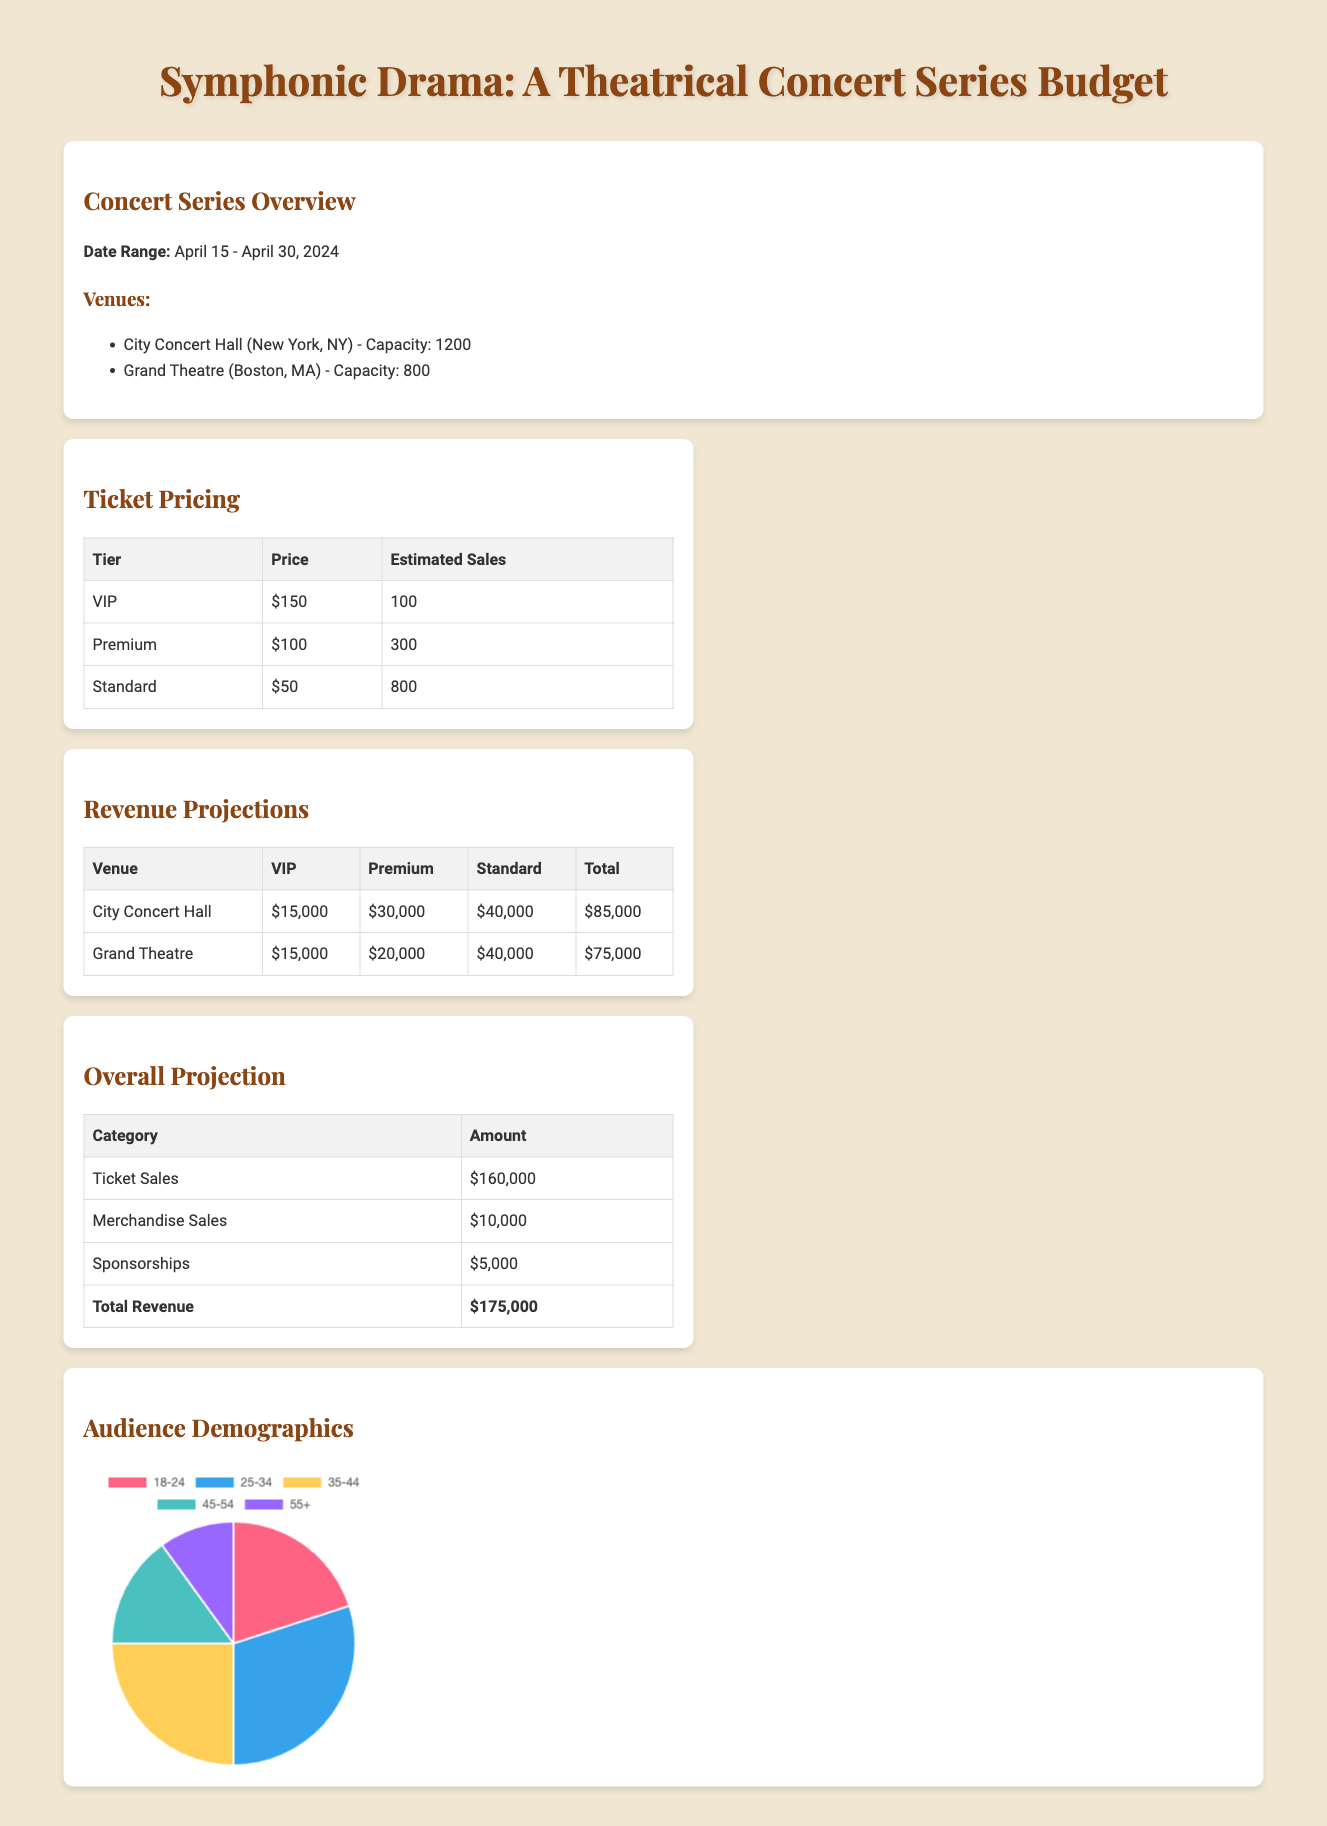What is the total projected ticket sales? The total projected ticket sales amount is listed under overall projection as $160,000.
Answer: $160,000 What is the capacity of the Grand Theatre? The capacity of the Grand Theatre is specified in the concert series overview as 800.
Answer: 800 How many estimated VIP tickets will be sold? The estimated sales for VIP tickets are provided in the ticket pricing section as 100.
Answer: 100 What is the price of a Premium ticket? The pricing tier for a Premium ticket is mentioned in the ticket pricing table as $100.
Answer: $100 What is the total revenue projection for the City Concert Hall? The total revenue for the City Concert Hall is calculated in the revenue projections table as $85,000.
Answer: $85,000 Which age group has the highest distribution in the audience demographics? The audience demographics pie chart data indicates that the 25-34 age group has the highest percentage at 30.
Answer: 25-34 What is the total revenue from merchandise sales? The total revenue from merchandise sales is outlined in the overall projection section as $10,000.
Answer: $10,000 What is the date range for the concert series? The concert series overview specifies the date range as April 15 - April 30, 2024.
Answer: April 15 - April 30, 2024 What is the total revenue projection for sponsorships? The amount projected for sponsorships is shown in the overall projection section as $5,000.
Answer: $5,000 